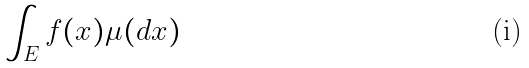Convert formula to latex. <formula><loc_0><loc_0><loc_500><loc_500>\int _ { E } f ( x ) \mu ( d x )</formula> 